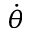Convert formula to latex. <formula><loc_0><loc_0><loc_500><loc_500>\dot { \theta }</formula> 